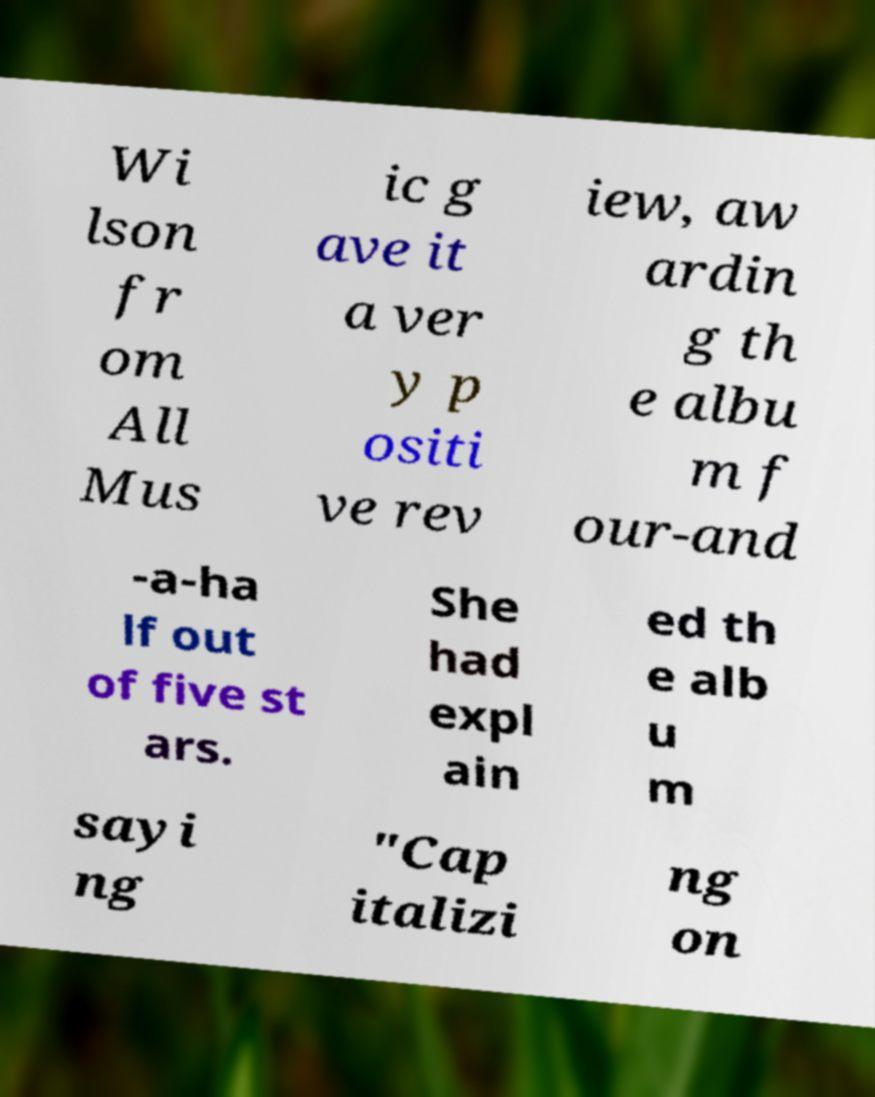I need the written content from this picture converted into text. Can you do that? Wi lson fr om All Mus ic g ave it a ver y p ositi ve rev iew, aw ardin g th e albu m f our-and -a-ha lf out of five st ars. She had expl ain ed th e alb u m sayi ng "Cap italizi ng on 